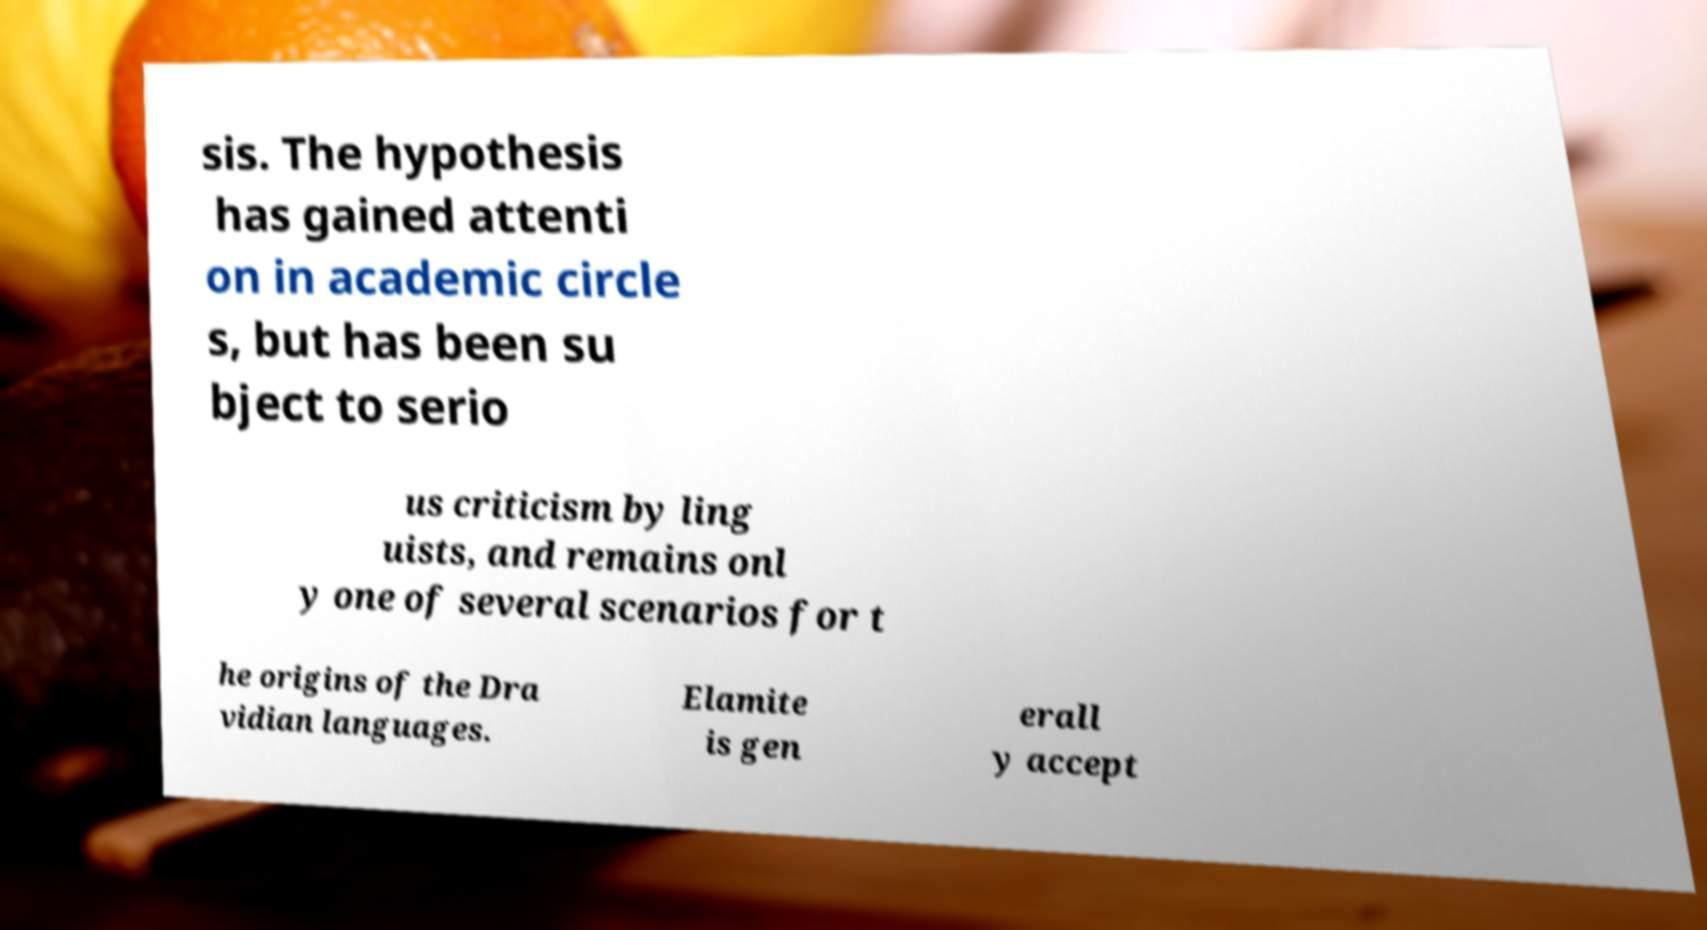I need the written content from this picture converted into text. Can you do that? sis. The hypothesis has gained attenti on in academic circle s, but has been su bject to serio us criticism by ling uists, and remains onl y one of several scenarios for t he origins of the Dra vidian languages. Elamite is gen erall y accept 